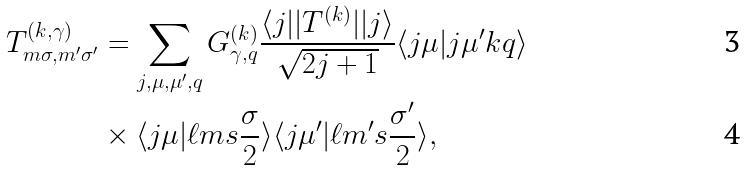<formula> <loc_0><loc_0><loc_500><loc_500>T ^ { ( k , \gamma ) } _ { m \sigma , m ^ { \prime } \sigma ^ { \prime } } & = \sum _ { j , \mu , \mu ^ { \prime } , q } G ^ { ( k ) } _ { \gamma , q } \frac { \langle j | | T ^ { ( k ) } | | j \rangle } { \sqrt { 2 j + 1 } } \langle j \mu | j \mu ^ { \prime } k q \rangle \\ & \times \langle j \mu | \ell m s \frac { \sigma } { 2 } \rangle \langle j \mu ^ { \prime } | \ell m ^ { \prime } s \frac { \sigma ^ { \prime } } { 2 } \rangle ,</formula> 